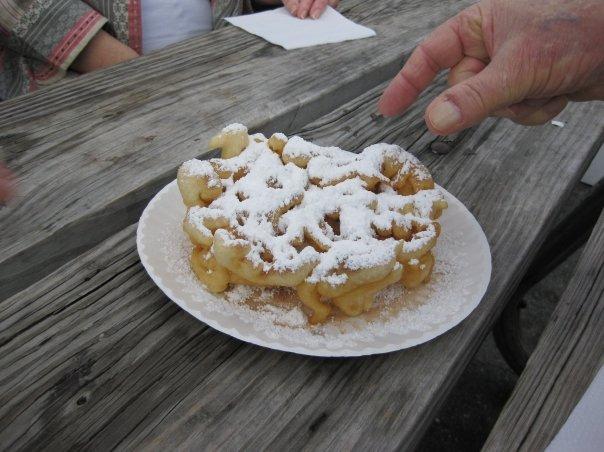What kind of food is this?
Be succinct. Funnel cake. Is this a dessert?
Short answer required. Yes. What type of sugar is on this?
Write a very short answer. Powdered. Is this a mahogany table?
Keep it brief. No. What is this food?
Keep it brief. Funnel cake. 